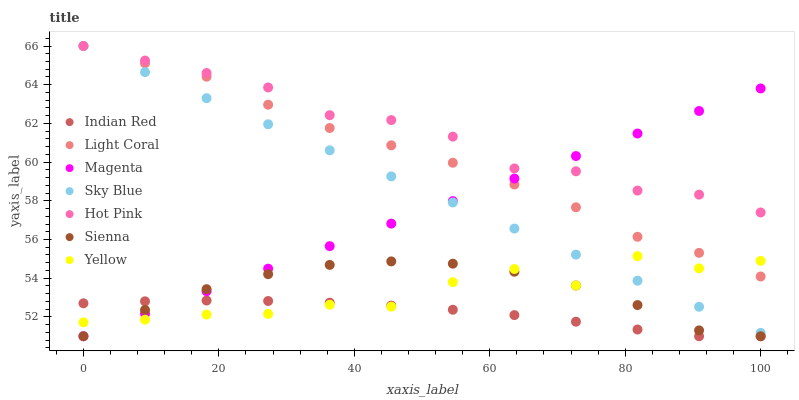Does Indian Red have the minimum area under the curve?
Answer yes or no. Yes. Does Hot Pink have the maximum area under the curve?
Answer yes or no. Yes. Does Yellow have the minimum area under the curve?
Answer yes or no. No. Does Yellow have the maximum area under the curve?
Answer yes or no. No. Is Magenta the smoothest?
Answer yes or no. Yes. Is Yellow the roughest?
Answer yes or no. Yes. Is Hot Pink the smoothest?
Answer yes or no. No. Is Hot Pink the roughest?
Answer yes or no. No. Does Sienna have the lowest value?
Answer yes or no. Yes. Does Yellow have the lowest value?
Answer yes or no. No. Does Sky Blue have the highest value?
Answer yes or no. Yes. Does Yellow have the highest value?
Answer yes or no. No. Is Sienna less than Sky Blue?
Answer yes or no. Yes. Is Light Coral greater than Indian Red?
Answer yes or no. Yes. Does Yellow intersect Light Coral?
Answer yes or no. Yes. Is Yellow less than Light Coral?
Answer yes or no. No. Is Yellow greater than Light Coral?
Answer yes or no. No. Does Sienna intersect Sky Blue?
Answer yes or no. No. 